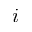<formula> <loc_0><loc_0><loc_500><loc_500>i</formula> 